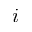<formula> <loc_0><loc_0><loc_500><loc_500>i</formula> 